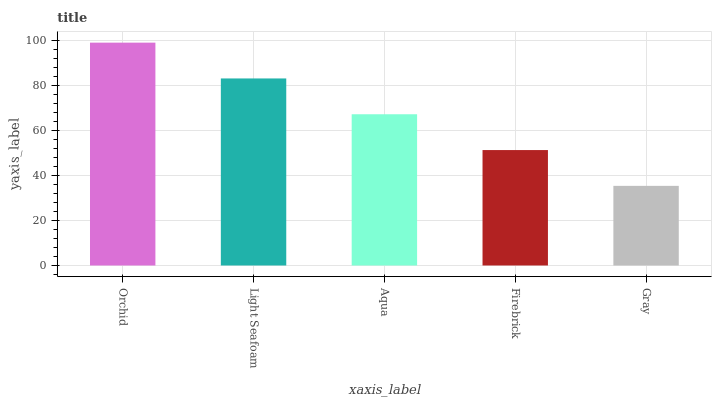Is Gray the minimum?
Answer yes or no. Yes. Is Orchid the maximum?
Answer yes or no. Yes. Is Light Seafoam the minimum?
Answer yes or no. No. Is Light Seafoam the maximum?
Answer yes or no. No. Is Orchid greater than Light Seafoam?
Answer yes or no. Yes. Is Light Seafoam less than Orchid?
Answer yes or no. Yes. Is Light Seafoam greater than Orchid?
Answer yes or no. No. Is Orchid less than Light Seafoam?
Answer yes or no. No. Is Aqua the high median?
Answer yes or no. Yes. Is Aqua the low median?
Answer yes or no. Yes. Is Firebrick the high median?
Answer yes or no. No. Is Orchid the low median?
Answer yes or no. No. 